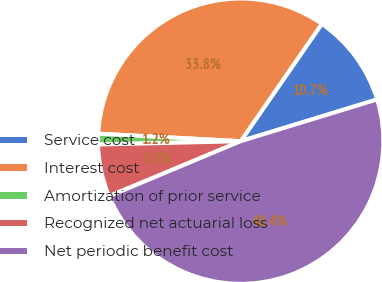Convert chart. <chart><loc_0><loc_0><loc_500><loc_500><pie_chart><fcel>Service cost<fcel>Interest cost<fcel>Amortization of prior service<fcel>Recognized net actuarial loss<fcel>Net periodic benefit cost<nl><fcel>10.65%<fcel>33.78%<fcel>1.21%<fcel>5.93%<fcel>48.42%<nl></chart> 